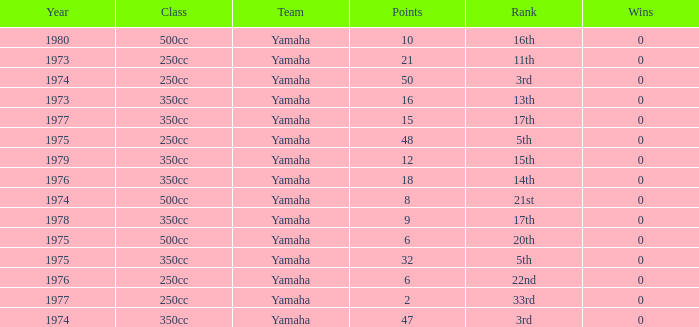How many points have a 17th rank and more than 0 wins? 0.0. 